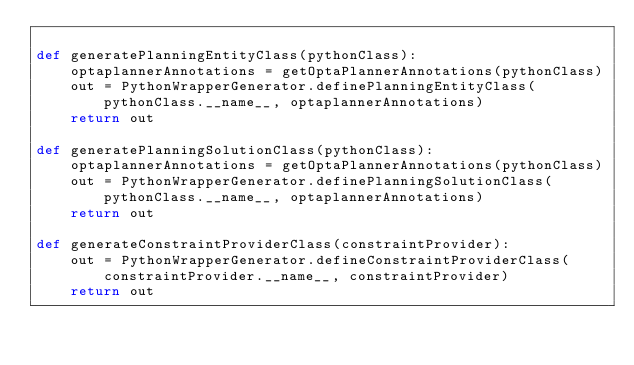Convert code to text. <code><loc_0><loc_0><loc_500><loc_500><_Python_>
def generatePlanningEntityClass(pythonClass):
    optaplannerAnnotations = getOptaPlannerAnnotations(pythonClass)
    out = PythonWrapperGenerator.definePlanningEntityClass(pythonClass.__name__, optaplannerAnnotations)
    return out

def generatePlanningSolutionClass(pythonClass):
    optaplannerAnnotations = getOptaPlannerAnnotations(pythonClass)
    out = PythonWrapperGenerator.definePlanningSolutionClass(pythonClass.__name__, optaplannerAnnotations)
    return out

def generateConstraintProviderClass(constraintProvider):
    out = PythonWrapperGenerator.defineConstraintProviderClass(constraintProvider.__name__, constraintProvider)
    return out</code> 